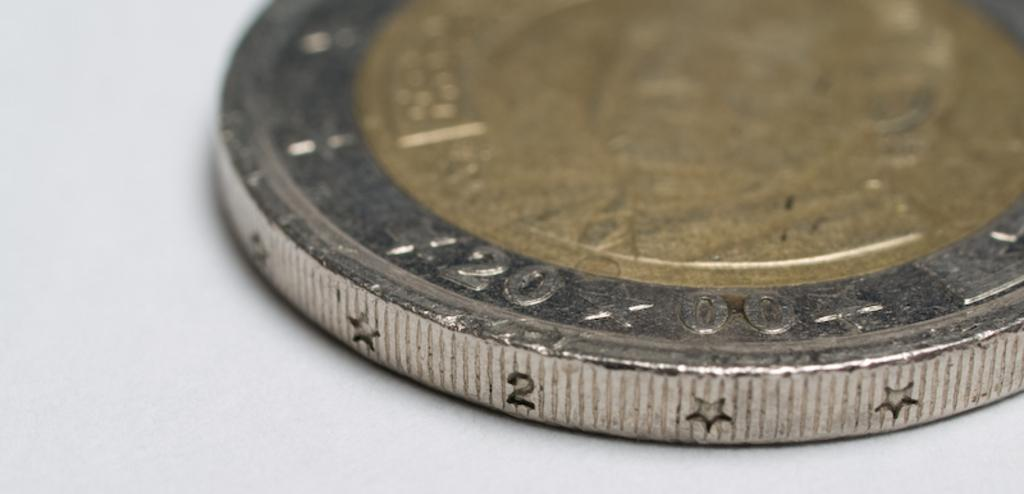Provide a one-sentence caption for the provided image. A coin minted in 2000 that features stars on the ridge. 